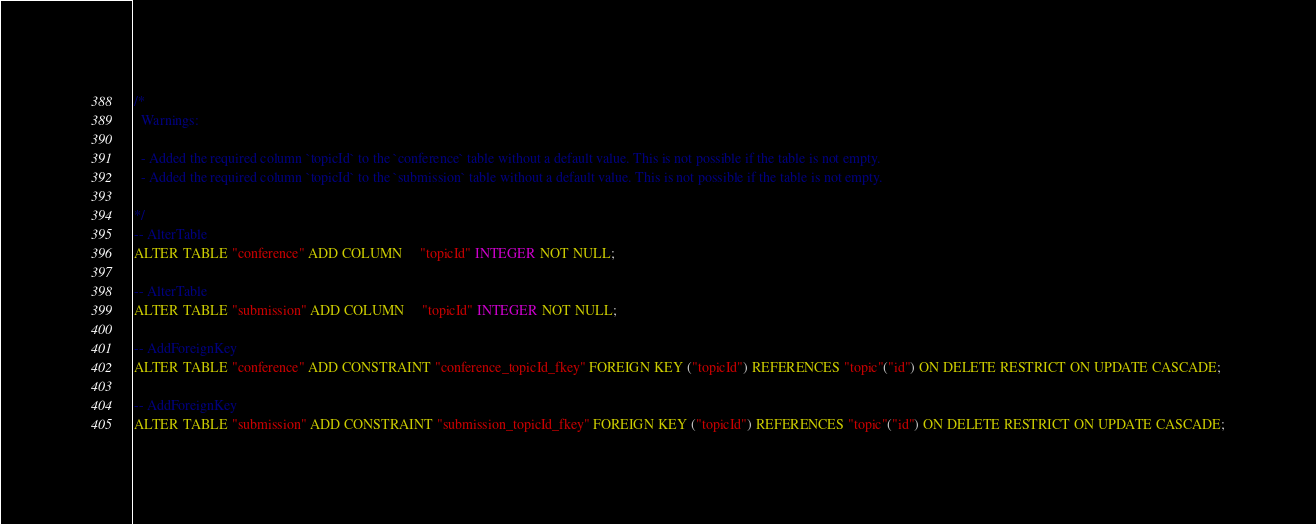<code> <loc_0><loc_0><loc_500><loc_500><_SQL_>/*
  Warnings:

  - Added the required column `topicId` to the `conference` table without a default value. This is not possible if the table is not empty.
  - Added the required column `topicId` to the `submission` table without a default value. This is not possible if the table is not empty.

*/
-- AlterTable
ALTER TABLE "conference" ADD COLUMN     "topicId" INTEGER NOT NULL;

-- AlterTable
ALTER TABLE "submission" ADD COLUMN     "topicId" INTEGER NOT NULL;

-- AddForeignKey
ALTER TABLE "conference" ADD CONSTRAINT "conference_topicId_fkey" FOREIGN KEY ("topicId") REFERENCES "topic"("id") ON DELETE RESTRICT ON UPDATE CASCADE;

-- AddForeignKey
ALTER TABLE "submission" ADD CONSTRAINT "submission_topicId_fkey" FOREIGN KEY ("topicId") REFERENCES "topic"("id") ON DELETE RESTRICT ON UPDATE CASCADE;
</code> 